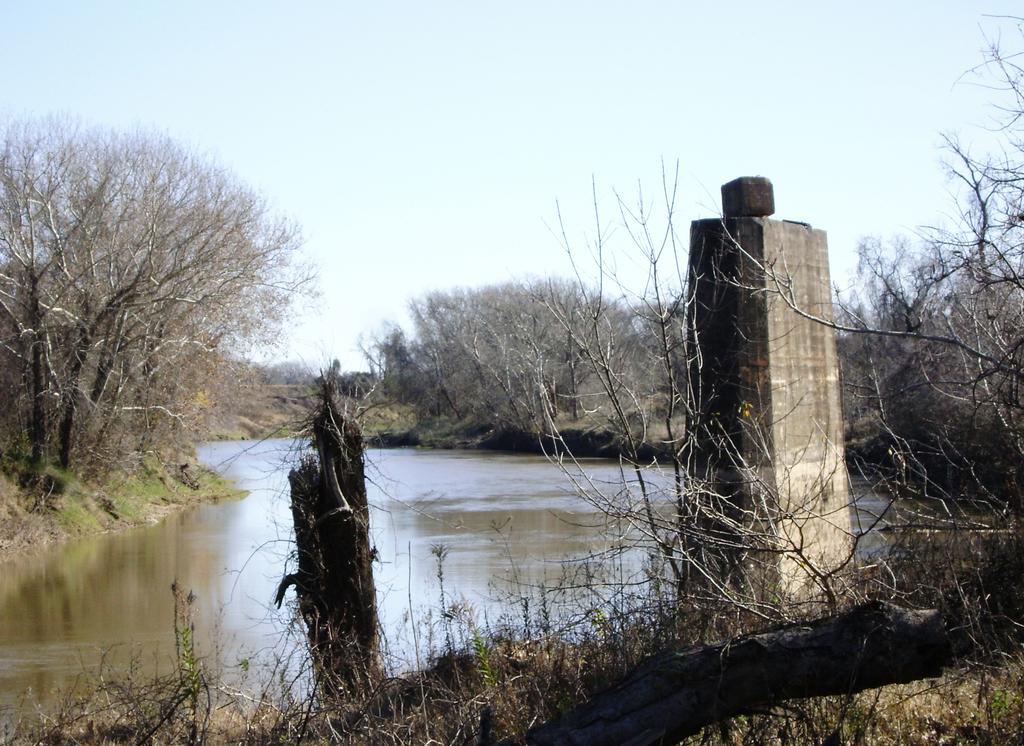Please provide a concise description of this image. This picture is taken from the outside of the city. In this image, on the right side, we can see some trees and plants. On the right side, we can also see a pillar. On the left side, we can see a wooden trunk. On the left side, we can see some trees and plants. In the middle of the image, we can see water in a lake. In the background, we can see some trees and plants. At the top, we can see a sky, at the bottom, we can see planets and a grass. 